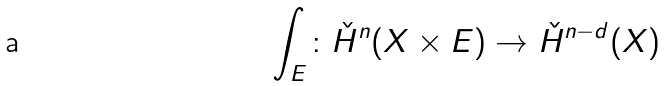Convert formula to latex. <formula><loc_0><loc_0><loc_500><loc_500>\int _ { E } \colon \check { H } ^ { n } ( X \times E ) \rightarrow \check { H } ^ { n - d } ( X )</formula> 